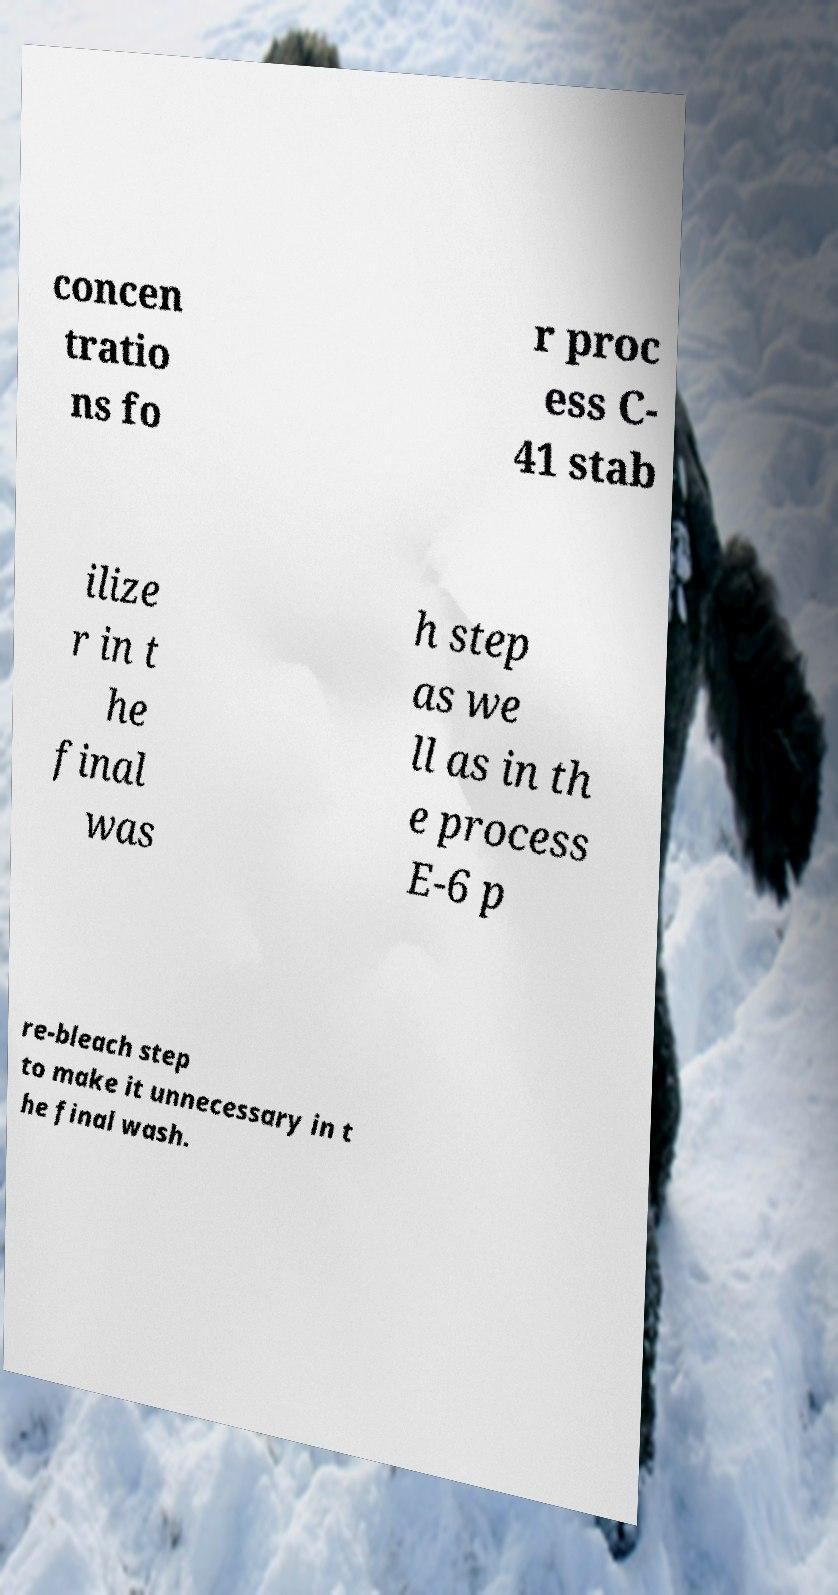Please read and relay the text visible in this image. What does it say? concen tratio ns fo r proc ess C- 41 stab ilize r in t he final was h step as we ll as in th e process E-6 p re-bleach step to make it unnecessary in t he final wash. 